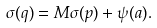Convert formula to latex. <formula><loc_0><loc_0><loc_500><loc_500>\sigma ( q ) & = M \sigma ( p ) + \psi ( a ) .</formula> 